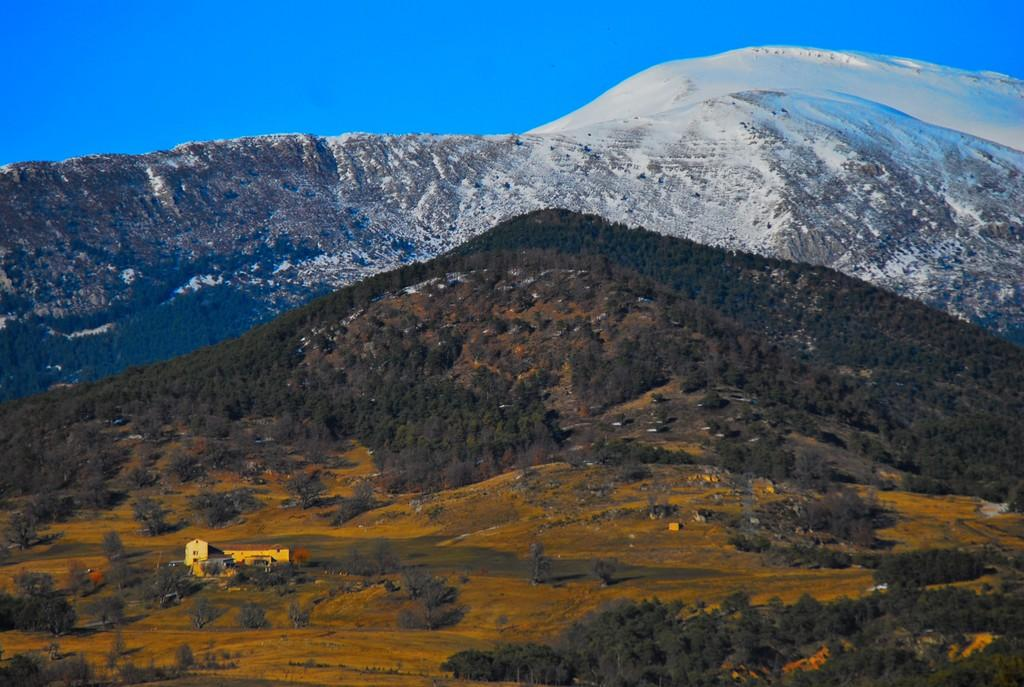What type of structure is in the picture? There is a house in the picture. What can be seen in the distance behind the house? Hills are visible in the background of the picture. What type of vegetation is present on the hills? Trees are present on the hills. How does the fear of heights affect the calculator in the image? There is no calculator present in the image, and the fear of heights is not relevant to the image. 